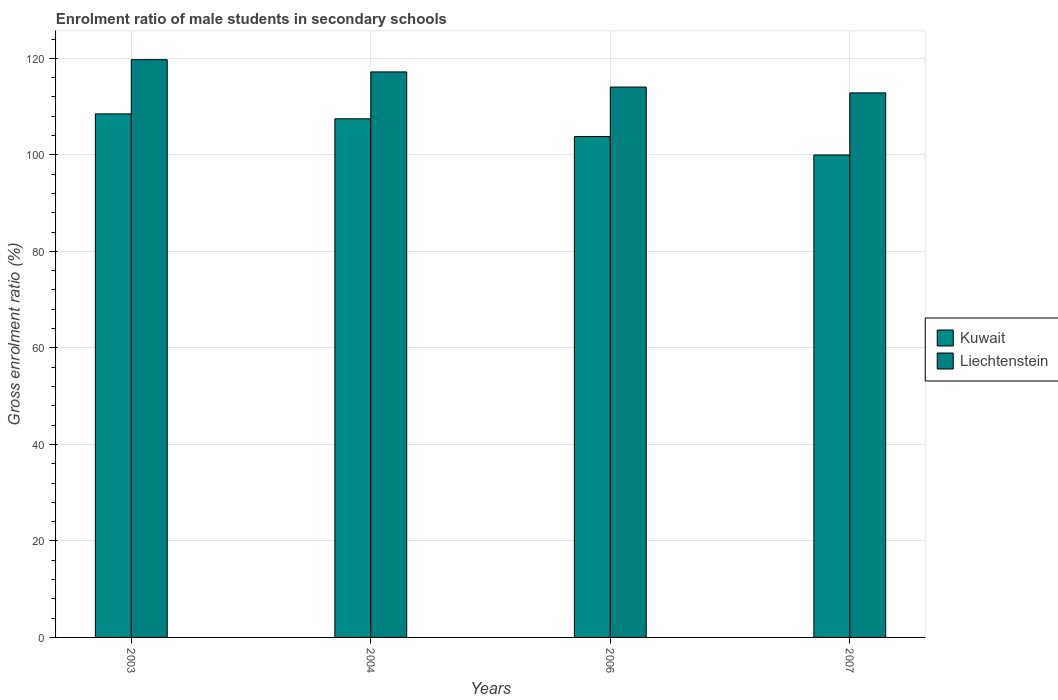How many different coloured bars are there?
Offer a terse response. 2. Are the number of bars per tick equal to the number of legend labels?
Provide a short and direct response. Yes. Are the number of bars on each tick of the X-axis equal?
Make the answer very short. Yes. How many bars are there on the 1st tick from the left?
Keep it short and to the point. 2. How many bars are there on the 4th tick from the right?
Your answer should be compact. 2. What is the label of the 3rd group of bars from the left?
Provide a short and direct response. 2006. In how many cases, is the number of bars for a given year not equal to the number of legend labels?
Your answer should be very brief. 0. What is the enrolment ratio of male students in secondary schools in Kuwait in 2003?
Your response must be concise. 108.49. Across all years, what is the maximum enrolment ratio of male students in secondary schools in Kuwait?
Provide a succinct answer. 108.49. Across all years, what is the minimum enrolment ratio of male students in secondary schools in Kuwait?
Offer a very short reply. 99.97. In which year was the enrolment ratio of male students in secondary schools in Liechtenstein maximum?
Give a very brief answer. 2003. In which year was the enrolment ratio of male students in secondary schools in Liechtenstein minimum?
Your answer should be very brief. 2007. What is the total enrolment ratio of male students in secondary schools in Kuwait in the graph?
Your answer should be very brief. 419.73. What is the difference between the enrolment ratio of male students in secondary schools in Liechtenstein in 2003 and that in 2007?
Your answer should be compact. 6.88. What is the difference between the enrolment ratio of male students in secondary schools in Kuwait in 2007 and the enrolment ratio of male students in secondary schools in Liechtenstein in 2003?
Your response must be concise. -19.75. What is the average enrolment ratio of male students in secondary schools in Kuwait per year?
Your answer should be compact. 104.93. In the year 2004, what is the difference between the enrolment ratio of male students in secondary schools in Liechtenstein and enrolment ratio of male students in secondary schools in Kuwait?
Your answer should be compact. 9.71. In how many years, is the enrolment ratio of male students in secondary schools in Kuwait greater than 44 %?
Ensure brevity in your answer.  4. What is the ratio of the enrolment ratio of male students in secondary schools in Liechtenstein in 2004 to that in 2007?
Your response must be concise. 1.04. Is the difference between the enrolment ratio of male students in secondary schools in Liechtenstein in 2004 and 2007 greater than the difference between the enrolment ratio of male students in secondary schools in Kuwait in 2004 and 2007?
Provide a succinct answer. No. What is the difference between the highest and the second highest enrolment ratio of male students in secondary schools in Liechtenstein?
Give a very brief answer. 2.53. What is the difference between the highest and the lowest enrolment ratio of male students in secondary schools in Kuwait?
Your answer should be compact. 8.52. What does the 1st bar from the left in 2003 represents?
Offer a very short reply. Kuwait. What does the 1st bar from the right in 2007 represents?
Keep it short and to the point. Liechtenstein. How many bars are there?
Ensure brevity in your answer.  8. What is the difference between two consecutive major ticks on the Y-axis?
Offer a very short reply. 20. Does the graph contain grids?
Offer a very short reply. Yes. Where does the legend appear in the graph?
Your answer should be compact. Center right. What is the title of the graph?
Keep it short and to the point. Enrolment ratio of male students in secondary schools. What is the Gross enrolment ratio (%) in Kuwait in 2003?
Your answer should be compact. 108.49. What is the Gross enrolment ratio (%) in Liechtenstein in 2003?
Provide a succinct answer. 119.72. What is the Gross enrolment ratio (%) in Kuwait in 2004?
Your answer should be very brief. 107.48. What is the Gross enrolment ratio (%) in Liechtenstein in 2004?
Provide a succinct answer. 117.19. What is the Gross enrolment ratio (%) in Kuwait in 2006?
Provide a succinct answer. 103.79. What is the Gross enrolment ratio (%) of Liechtenstein in 2006?
Provide a short and direct response. 114.05. What is the Gross enrolment ratio (%) of Kuwait in 2007?
Provide a short and direct response. 99.97. What is the Gross enrolment ratio (%) of Liechtenstein in 2007?
Provide a succinct answer. 112.84. Across all years, what is the maximum Gross enrolment ratio (%) of Kuwait?
Offer a very short reply. 108.49. Across all years, what is the maximum Gross enrolment ratio (%) in Liechtenstein?
Provide a short and direct response. 119.72. Across all years, what is the minimum Gross enrolment ratio (%) of Kuwait?
Your answer should be very brief. 99.97. Across all years, what is the minimum Gross enrolment ratio (%) of Liechtenstein?
Offer a terse response. 112.84. What is the total Gross enrolment ratio (%) in Kuwait in the graph?
Provide a short and direct response. 419.73. What is the total Gross enrolment ratio (%) in Liechtenstein in the graph?
Offer a terse response. 463.8. What is the difference between the Gross enrolment ratio (%) in Kuwait in 2003 and that in 2004?
Your answer should be very brief. 1.02. What is the difference between the Gross enrolment ratio (%) in Liechtenstein in 2003 and that in 2004?
Ensure brevity in your answer.  2.53. What is the difference between the Gross enrolment ratio (%) of Kuwait in 2003 and that in 2006?
Offer a very short reply. 4.7. What is the difference between the Gross enrolment ratio (%) in Liechtenstein in 2003 and that in 2006?
Your answer should be compact. 5.67. What is the difference between the Gross enrolment ratio (%) of Kuwait in 2003 and that in 2007?
Your answer should be compact. 8.52. What is the difference between the Gross enrolment ratio (%) in Liechtenstein in 2003 and that in 2007?
Offer a very short reply. 6.88. What is the difference between the Gross enrolment ratio (%) in Kuwait in 2004 and that in 2006?
Your response must be concise. 3.69. What is the difference between the Gross enrolment ratio (%) of Liechtenstein in 2004 and that in 2006?
Your response must be concise. 3.14. What is the difference between the Gross enrolment ratio (%) of Kuwait in 2004 and that in 2007?
Your answer should be compact. 7.5. What is the difference between the Gross enrolment ratio (%) of Liechtenstein in 2004 and that in 2007?
Offer a very short reply. 4.35. What is the difference between the Gross enrolment ratio (%) of Kuwait in 2006 and that in 2007?
Provide a succinct answer. 3.82. What is the difference between the Gross enrolment ratio (%) in Liechtenstein in 2006 and that in 2007?
Offer a very short reply. 1.21. What is the difference between the Gross enrolment ratio (%) in Kuwait in 2003 and the Gross enrolment ratio (%) in Liechtenstein in 2004?
Ensure brevity in your answer.  -8.7. What is the difference between the Gross enrolment ratio (%) in Kuwait in 2003 and the Gross enrolment ratio (%) in Liechtenstein in 2006?
Make the answer very short. -5.56. What is the difference between the Gross enrolment ratio (%) of Kuwait in 2003 and the Gross enrolment ratio (%) of Liechtenstein in 2007?
Ensure brevity in your answer.  -4.34. What is the difference between the Gross enrolment ratio (%) in Kuwait in 2004 and the Gross enrolment ratio (%) in Liechtenstein in 2006?
Your answer should be very brief. -6.57. What is the difference between the Gross enrolment ratio (%) of Kuwait in 2004 and the Gross enrolment ratio (%) of Liechtenstein in 2007?
Your response must be concise. -5.36. What is the difference between the Gross enrolment ratio (%) in Kuwait in 2006 and the Gross enrolment ratio (%) in Liechtenstein in 2007?
Your answer should be very brief. -9.05. What is the average Gross enrolment ratio (%) of Kuwait per year?
Keep it short and to the point. 104.93. What is the average Gross enrolment ratio (%) of Liechtenstein per year?
Your response must be concise. 115.95. In the year 2003, what is the difference between the Gross enrolment ratio (%) in Kuwait and Gross enrolment ratio (%) in Liechtenstein?
Offer a terse response. -11.23. In the year 2004, what is the difference between the Gross enrolment ratio (%) of Kuwait and Gross enrolment ratio (%) of Liechtenstein?
Your response must be concise. -9.71. In the year 2006, what is the difference between the Gross enrolment ratio (%) of Kuwait and Gross enrolment ratio (%) of Liechtenstein?
Your answer should be compact. -10.26. In the year 2007, what is the difference between the Gross enrolment ratio (%) in Kuwait and Gross enrolment ratio (%) in Liechtenstein?
Your response must be concise. -12.86. What is the ratio of the Gross enrolment ratio (%) of Kuwait in 2003 to that in 2004?
Your response must be concise. 1.01. What is the ratio of the Gross enrolment ratio (%) in Liechtenstein in 2003 to that in 2004?
Give a very brief answer. 1.02. What is the ratio of the Gross enrolment ratio (%) in Kuwait in 2003 to that in 2006?
Your answer should be compact. 1.05. What is the ratio of the Gross enrolment ratio (%) of Liechtenstein in 2003 to that in 2006?
Make the answer very short. 1.05. What is the ratio of the Gross enrolment ratio (%) of Kuwait in 2003 to that in 2007?
Provide a short and direct response. 1.09. What is the ratio of the Gross enrolment ratio (%) of Liechtenstein in 2003 to that in 2007?
Your answer should be very brief. 1.06. What is the ratio of the Gross enrolment ratio (%) in Kuwait in 2004 to that in 2006?
Your answer should be very brief. 1.04. What is the ratio of the Gross enrolment ratio (%) of Liechtenstein in 2004 to that in 2006?
Provide a succinct answer. 1.03. What is the ratio of the Gross enrolment ratio (%) in Kuwait in 2004 to that in 2007?
Provide a succinct answer. 1.08. What is the ratio of the Gross enrolment ratio (%) of Liechtenstein in 2004 to that in 2007?
Offer a terse response. 1.04. What is the ratio of the Gross enrolment ratio (%) of Kuwait in 2006 to that in 2007?
Offer a terse response. 1.04. What is the ratio of the Gross enrolment ratio (%) in Liechtenstein in 2006 to that in 2007?
Provide a short and direct response. 1.01. What is the difference between the highest and the second highest Gross enrolment ratio (%) in Kuwait?
Offer a very short reply. 1.02. What is the difference between the highest and the second highest Gross enrolment ratio (%) of Liechtenstein?
Your response must be concise. 2.53. What is the difference between the highest and the lowest Gross enrolment ratio (%) in Kuwait?
Your answer should be very brief. 8.52. What is the difference between the highest and the lowest Gross enrolment ratio (%) of Liechtenstein?
Make the answer very short. 6.88. 